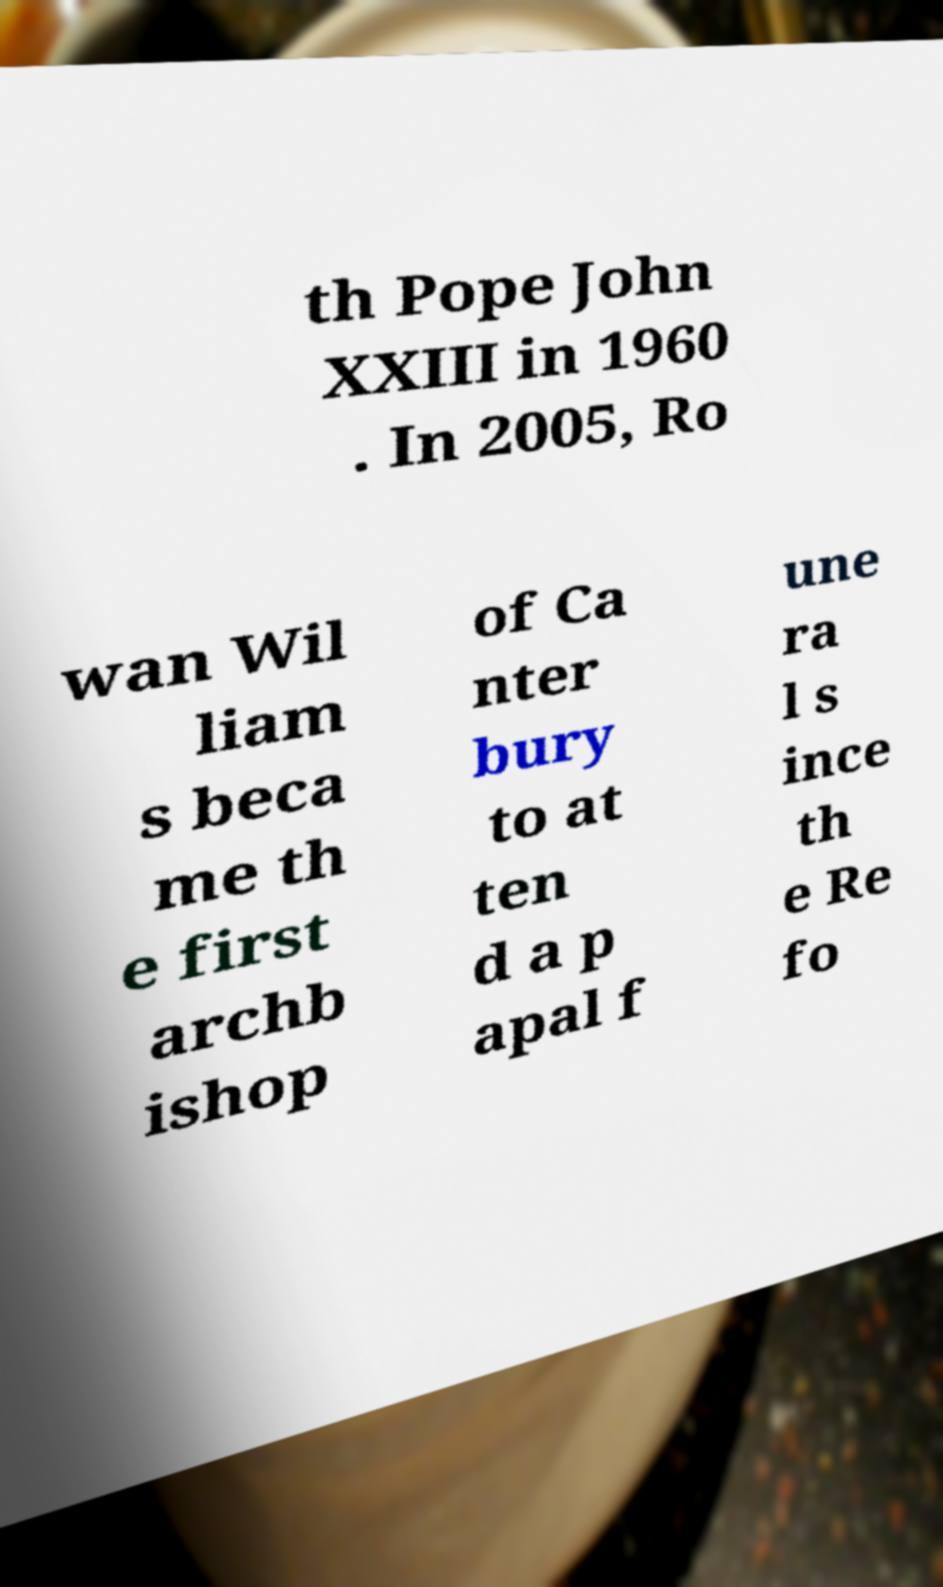Can you accurately transcribe the text from the provided image for me? th Pope John XXIII in 1960 . In 2005, Ro wan Wil liam s beca me th e first archb ishop of Ca nter bury to at ten d a p apal f une ra l s ince th e Re fo 